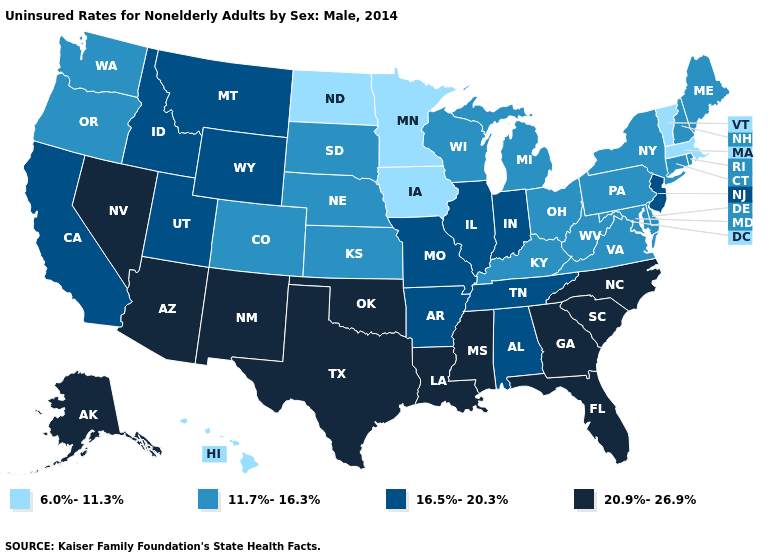What is the value of Illinois?
Write a very short answer. 16.5%-20.3%. Name the states that have a value in the range 6.0%-11.3%?
Answer briefly. Hawaii, Iowa, Massachusetts, Minnesota, North Dakota, Vermont. Does the first symbol in the legend represent the smallest category?
Keep it brief. Yes. Name the states that have a value in the range 16.5%-20.3%?
Short answer required. Alabama, Arkansas, California, Idaho, Illinois, Indiana, Missouri, Montana, New Jersey, Tennessee, Utah, Wyoming. What is the lowest value in the USA?
Concise answer only. 6.0%-11.3%. Does the map have missing data?
Quick response, please. No. How many symbols are there in the legend?
Give a very brief answer. 4. Does the map have missing data?
Quick response, please. No. Name the states that have a value in the range 6.0%-11.3%?
Be succinct. Hawaii, Iowa, Massachusetts, Minnesota, North Dakota, Vermont. Name the states that have a value in the range 20.9%-26.9%?
Give a very brief answer. Alaska, Arizona, Florida, Georgia, Louisiana, Mississippi, Nevada, New Mexico, North Carolina, Oklahoma, South Carolina, Texas. Name the states that have a value in the range 16.5%-20.3%?
Concise answer only. Alabama, Arkansas, California, Idaho, Illinois, Indiana, Missouri, Montana, New Jersey, Tennessee, Utah, Wyoming. Name the states that have a value in the range 16.5%-20.3%?
Write a very short answer. Alabama, Arkansas, California, Idaho, Illinois, Indiana, Missouri, Montana, New Jersey, Tennessee, Utah, Wyoming. Name the states that have a value in the range 16.5%-20.3%?
Answer briefly. Alabama, Arkansas, California, Idaho, Illinois, Indiana, Missouri, Montana, New Jersey, Tennessee, Utah, Wyoming. Name the states that have a value in the range 11.7%-16.3%?
Quick response, please. Colorado, Connecticut, Delaware, Kansas, Kentucky, Maine, Maryland, Michigan, Nebraska, New Hampshire, New York, Ohio, Oregon, Pennsylvania, Rhode Island, South Dakota, Virginia, Washington, West Virginia, Wisconsin. Name the states that have a value in the range 11.7%-16.3%?
Concise answer only. Colorado, Connecticut, Delaware, Kansas, Kentucky, Maine, Maryland, Michigan, Nebraska, New Hampshire, New York, Ohio, Oregon, Pennsylvania, Rhode Island, South Dakota, Virginia, Washington, West Virginia, Wisconsin. 